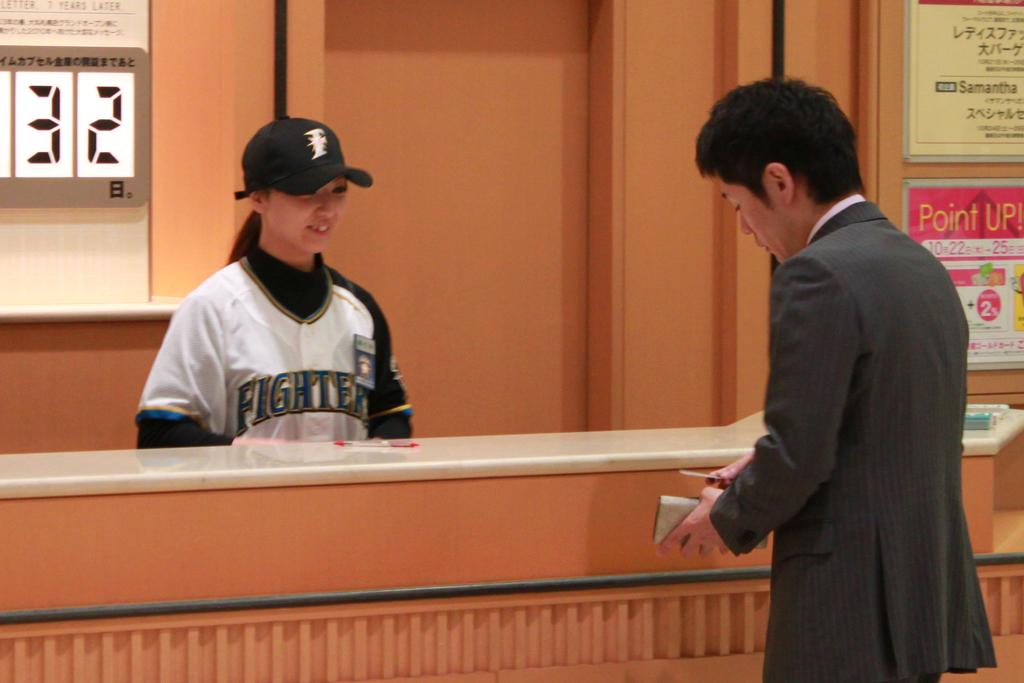<image>
Write a terse but informative summary of the picture. Person wearing a jersey that says the word "Fighter" on it. 